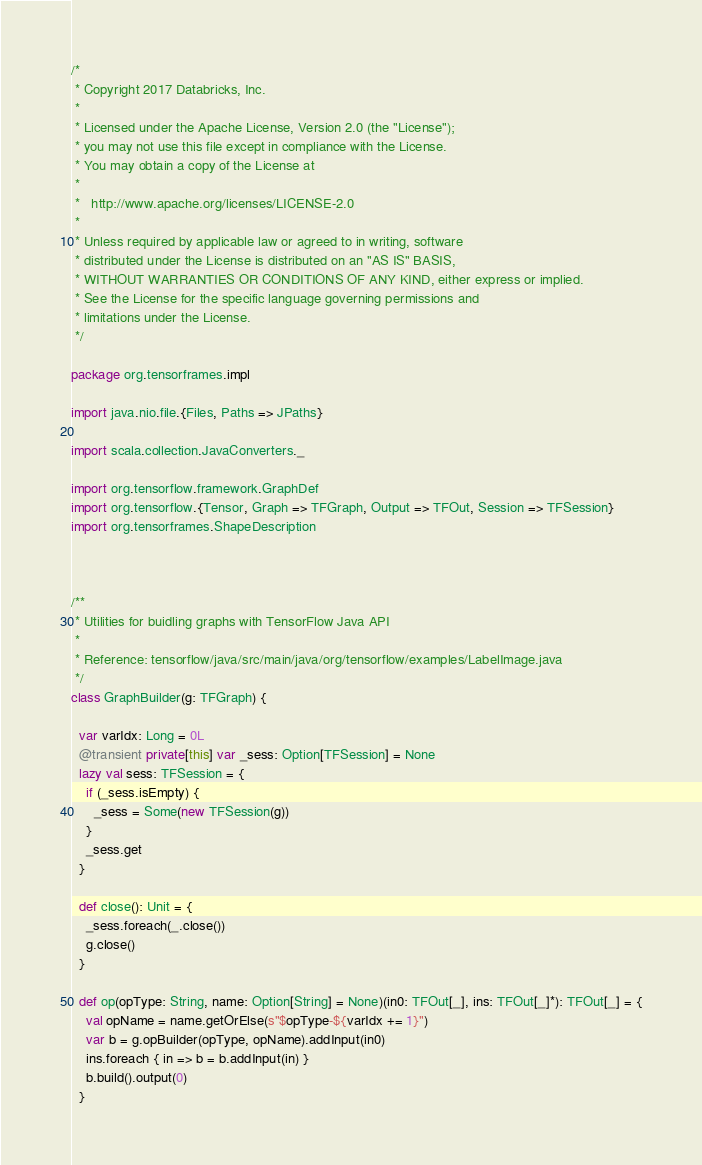Convert code to text. <code><loc_0><loc_0><loc_500><loc_500><_Scala_>/*
 * Copyright 2017 Databricks, Inc.
 *
 * Licensed under the Apache License, Version 2.0 (the "License");
 * you may not use this file except in compliance with the License.
 * You may obtain a copy of the License at
 *
 *   http://www.apache.org/licenses/LICENSE-2.0
 *
 * Unless required by applicable law or agreed to in writing, software
 * distributed under the License is distributed on an "AS IS" BASIS,
 * WITHOUT WARRANTIES OR CONDITIONS OF ANY KIND, either express or implied.
 * See the License for the specific language governing permissions and
 * limitations under the License.
 */

package org.tensorframes.impl

import java.nio.file.{Files, Paths => JPaths}

import scala.collection.JavaConverters._

import org.tensorflow.framework.GraphDef
import org.tensorflow.{Tensor, Graph => TFGraph, Output => TFOut, Session => TFSession}
import org.tensorframes.ShapeDescription



/**
 * Utilities for buidling graphs with TensorFlow Java API
 * 
 * Reference: tensorflow/java/src/main/java/org/tensorflow/examples/LabelImage.java
 */
class GraphBuilder(g: TFGraph) {

  var varIdx: Long = 0L  
  @transient private[this] var _sess: Option[TFSession] = None
  lazy val sess: TFSession = {
    if (_sess.isEmpty) {
      _sess = Some(new TFSession(g))
    }
    _sess.get
  }

  def close(): Unit = {
    _sess.foreach(_.close())
    g.close()
  }

  def op(opType: String, name: Option[String] = None)(in0: TFOut[_], ins: TFOut[_]*): TFOut[_] = {
    val opName = name.getOrElse(s"$opType-${varIdx += 1}")
    var b = g.opBuilder(opType, opName).addInput(in0)
    ins.foreach { in => b = b.addInput(in) }
    b.build().output(0)
  }  
</code> 